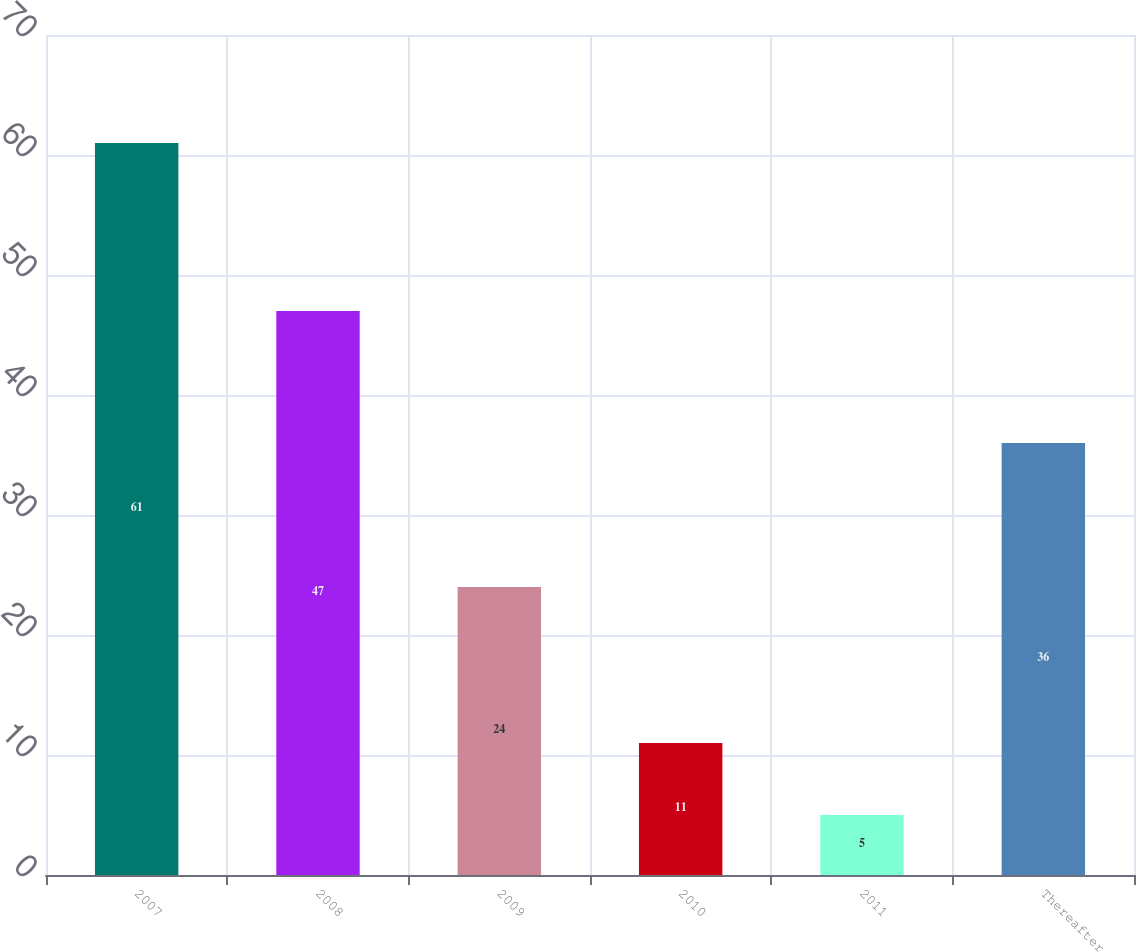<chart> <loc_0><loc_0><loc_500><loc_500><bar_chart><fcel>2007<fcel>2008<fcel>2009<fcel>2010<fcel>2011<fcel>Thereafter<nl><fcel>61<fcel>47<fcel>24<fcel>11<fcel>5<fcel>36<nl></chart> 